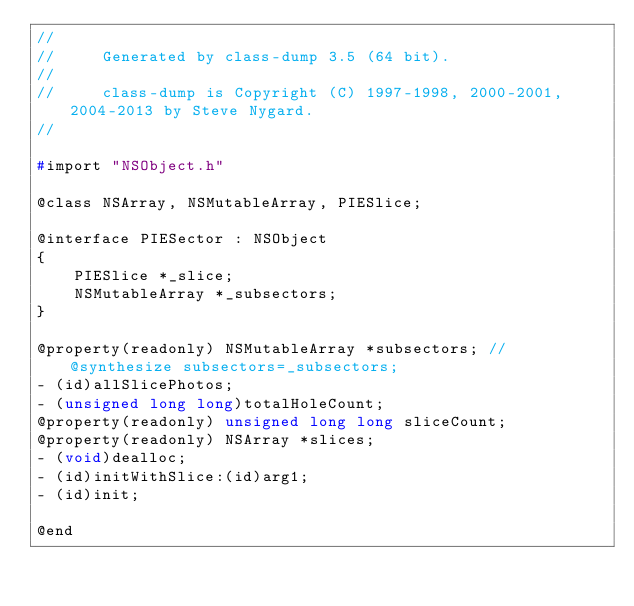Convert code to text. <code><loc_0><loc_0><loc_500><loc_500><_C_>//
//     Generated by class-dump 3.5 (64 bit).
//
//     class-dump is Copyright (C) 1997-1998, 2000-2001, 2004-2013 by Steve Nygard.
//

#import "NSObject.h"

@class NSArray, NSMutableArray, PIESlice;

@interface PIESector : NSObject
{
    PIESlice *_slice;
    NSMutableArray *_subsectors;
}

@property(readonly) NSMutableArray *subsectors; // @synthesize subsectors=_subsectors;
- (id)allSlicePhotos;
- (unsigned long long)totalHoleCount;
@property(readonly) unsigned long long sliceCount;
@property(readonly) NSArray *slices;
- (void)dealloc;
- (id)initWithSlice:(id)arg1;
- (id)init;

@end

</code> 